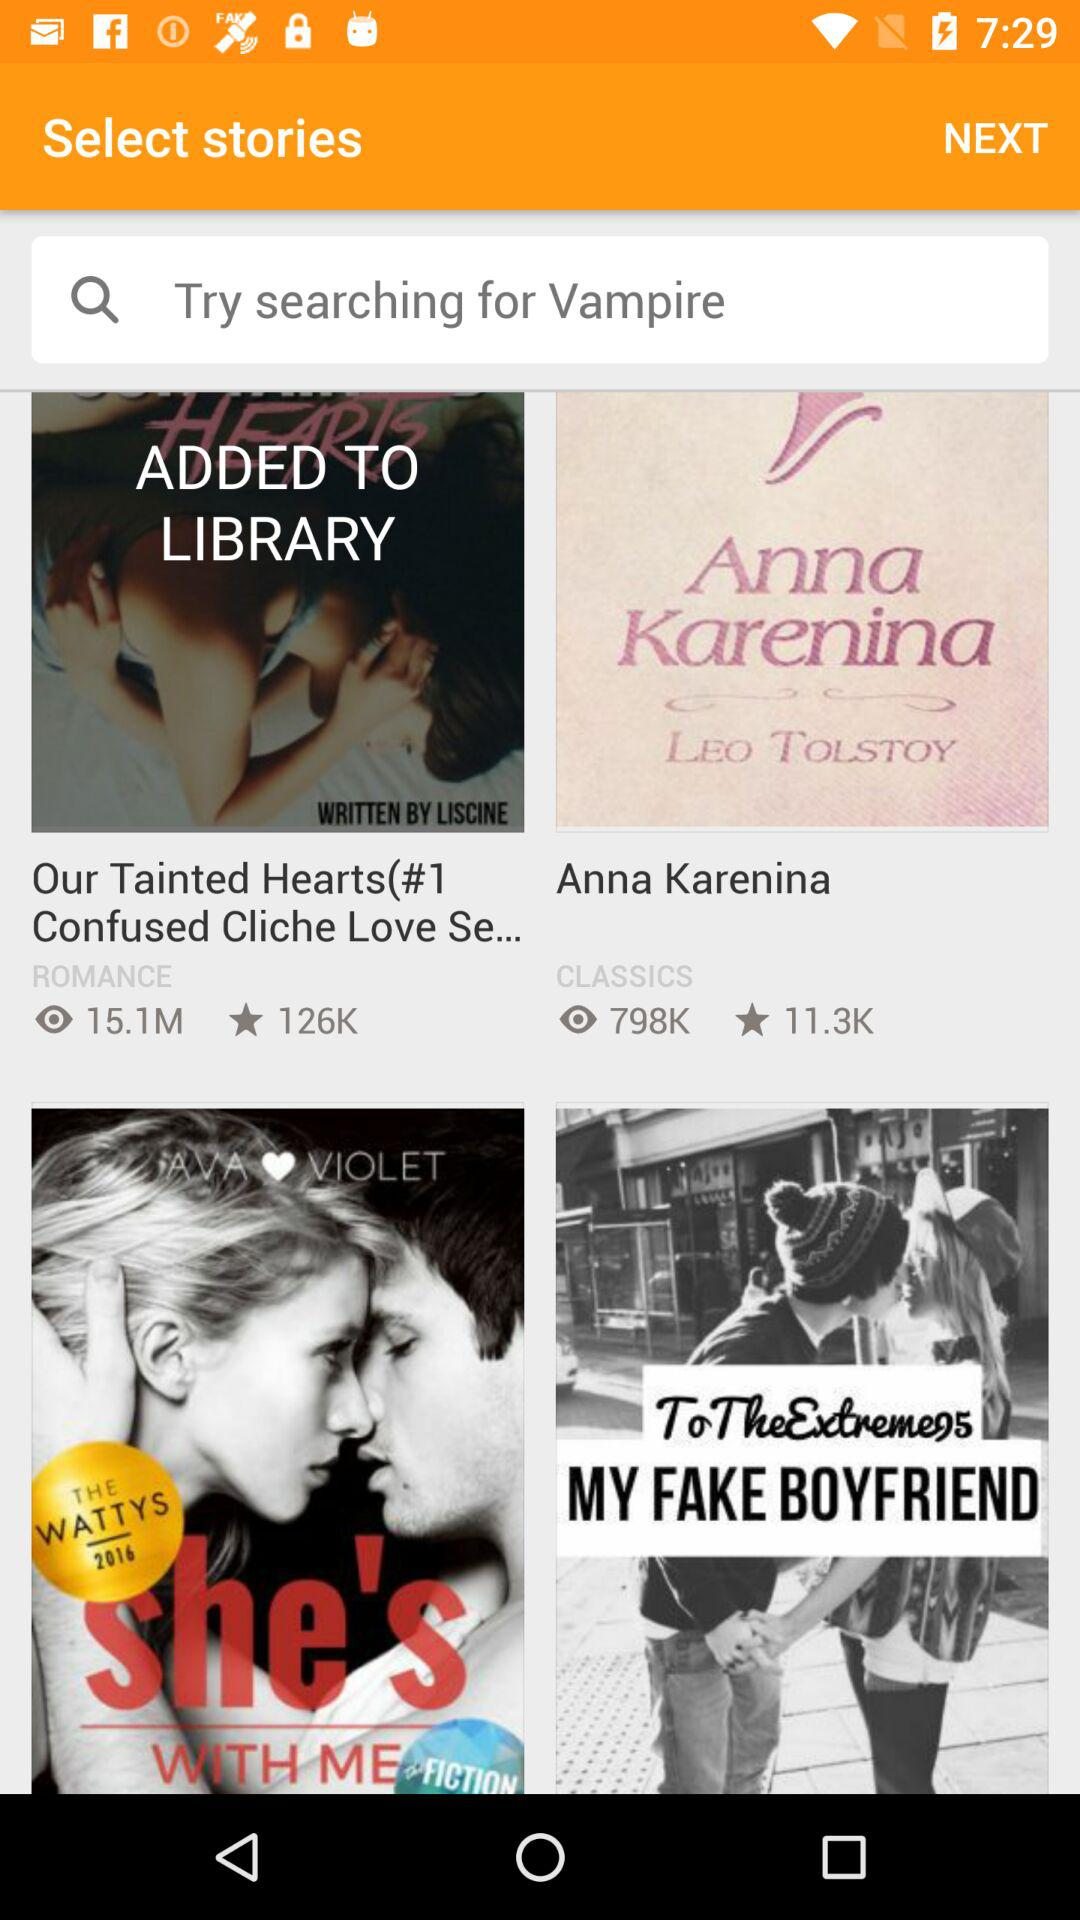How many views are there for "Anna Karenina"? There are 798K views. 